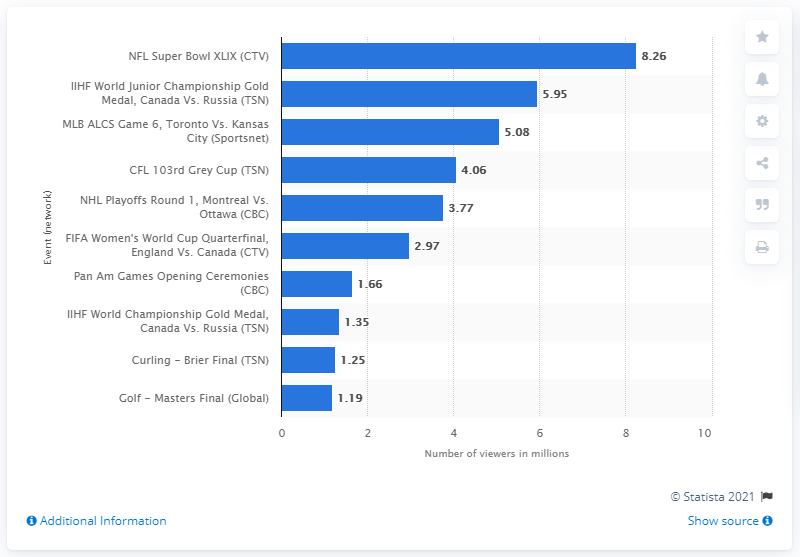Outline some significant characteristics in this image. In 2015, the Super Bowl attracted a record-breaking 8.26 million viewers, making it one of the most watched television events in history. 